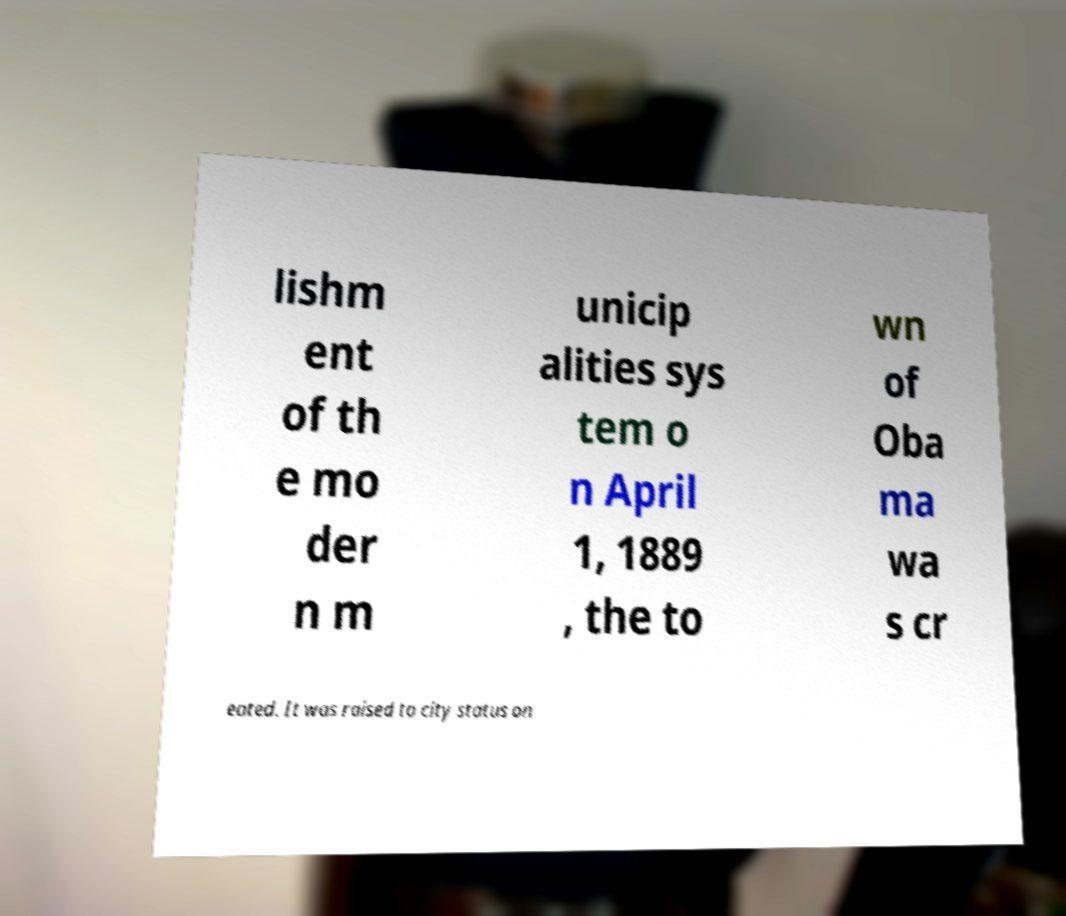For documentation purposes, I need the text within this image transcribed. Could you provide that? lishm ent of th e mo der n m unicip alities sys tem o n April 1, 1889 , the to wn of Oba ma wa s cr eated. It was raised to city status on 